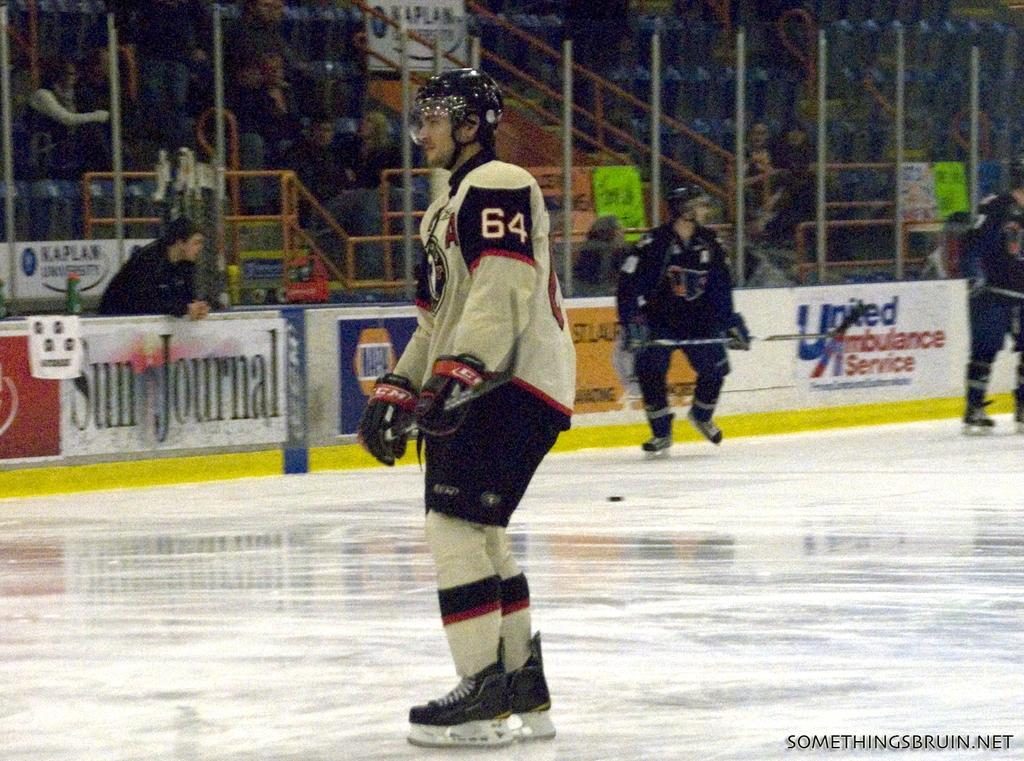<image>
Give a short and clear explanation of the subsequent image. Hocket player number 64 stands on the ice with a Sun Journal advertisement behind him. 